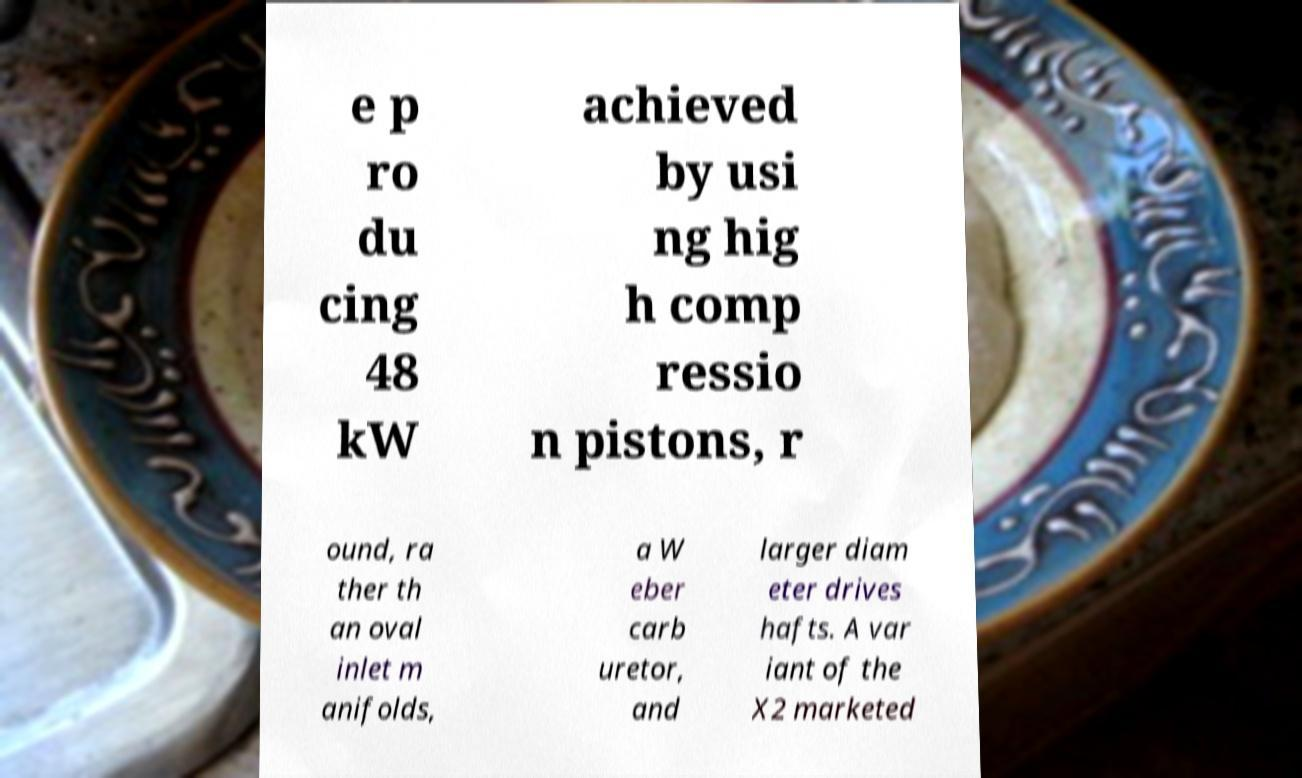Can you read and provide the text displayed in the image?This photo seems to have some interesting text. Can you extract and type it out for me? e p ro du cing 48 kW achieved by usi ng hig h comp ressio n pistons, r ound, ra ther th an oval inlet m anifolds, a W eber carb uretor, and larger diam eter drives hafts. A var iant of the X2 marketed 